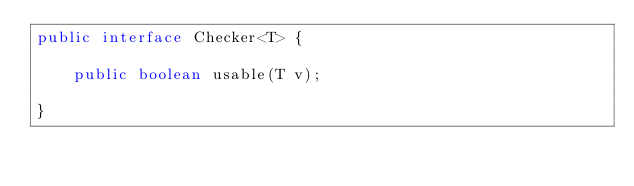<code> <loc_0><loc_0><loc_500><loc_500><_Java_>public interface Checker<T> {
	
    public boolean usable(T v);
    
}
</code> 